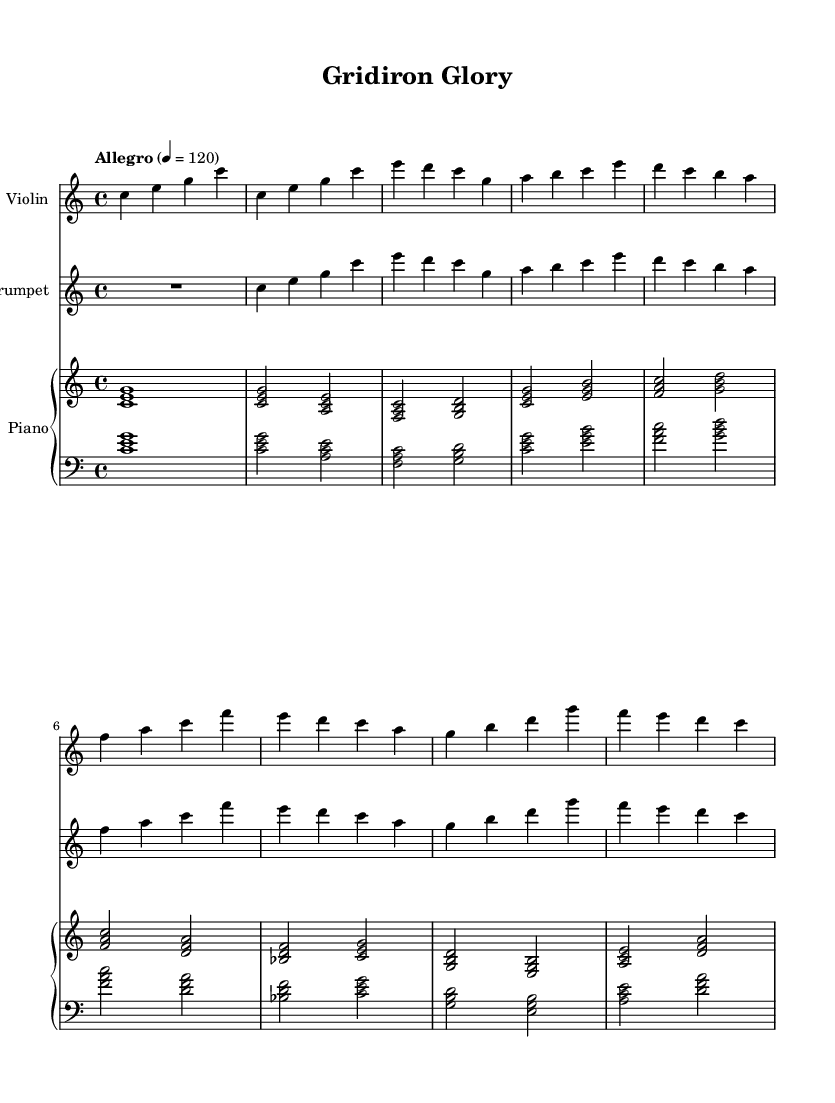What is the key signature of this music? The key signature indicated at the beginning shows that the piece is in C major, which contains no sharps or flats.
Answer: C major What is the time signature of the music? The time signature is found at the beginning of the score, indicated as 4/4, meaning there are four beats in each measure.
Answer: 4/4 What is the tempo marking for this piece? The tempo is specified as "Allegro" with a marking of quarter note equals 120, which defines the speed of the piece.
Answer: Allegro 120 How many measures are present in this score? By counting the measures in the provided sections, there are a total of 16 measures visible in the main themes.
Answer: 16 Which instrument has a rest in the introduction? The trumpet part has a rest indicated at the beginning, followed by the melodic material, while the violin and piano start playing immediately.
Answer: Trumpet What is the main theme noted in the violin part? The main theme consists of a sequence of notes starting with C, moving through the melodies in the theme A section. The specific notes can be traced directly on the sheet.
Answer: C E G What type of musical score is represented here? The music is an orchestral arrangement, featuring multiple instruments including a violin, trumpet, and piano, creating a rich texture typical for sports documentaries.
Answer: Orchestral 